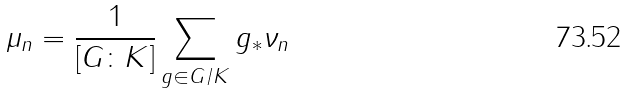<formula> <loc_0><loc_0><loc_500><loc_500>\mu _ { n } = \frac { 1 } { \left [ G \colon K \right ] } \sum _ { g \in G / K } g _ { * } \nu _ { n }</formula> 